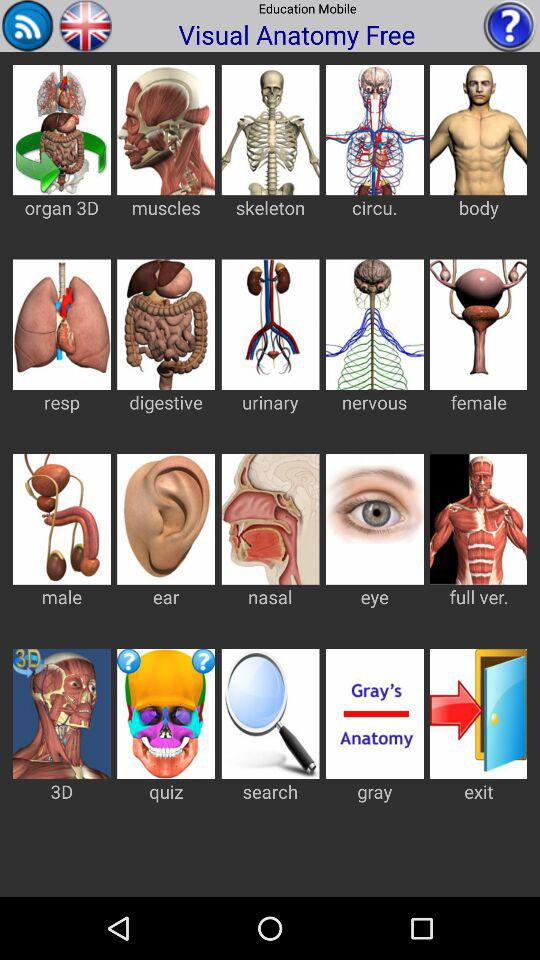What are the different kinds of visual anatomy available? The different kinds of visual anatomy are "organ 3D", "muscles", "skeleton", "circu.", "body", "resp", "digestive", "urinary", "nervous", "female", "male", "ear", "nasal", "eye", "full ver.", "3D", "quiz", "search", "gray" and "exit". 